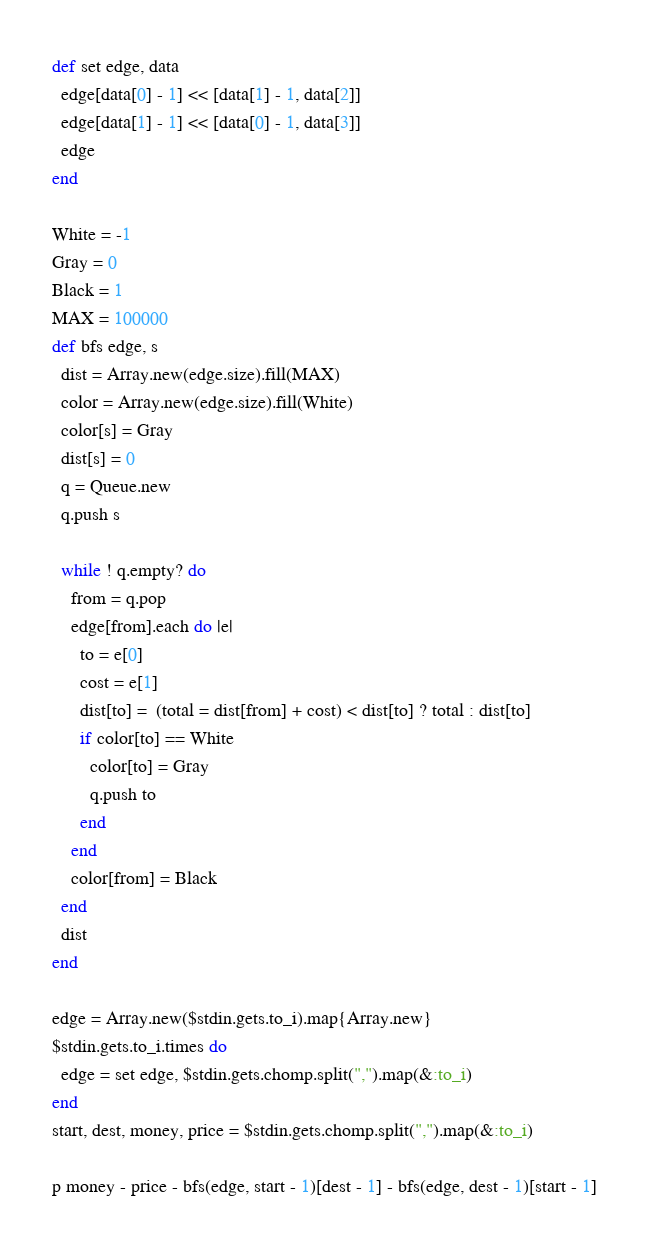Convert code to text. <code><loc_0><loc_0><loc_500><loc_500><_Ruby_>def set edge, data
  edge[data[0] - 1] << [data[1] - 1, data[2]]
  edge[data[1] - 1] << [data[0] - 1, data[3]]
  edge
end

White = -1
Gray = 0
Black = 1
MAX = 100000
def bfs edge, s
  dist = Array.new(edge.size).fill(MAX)
  color = Array.new(edge.size).fill(White)
  color[s] = Gray
  dist[s] = 0
  q = Queue.new
  q.push s

  while ! q.empty? do
    from = q.pop
    edge[from].each do |e|
      to = e[0]
      cost = e[1]
      dist[to] =  (total = dist[from] + cost) < dist[to] ? total : dist[to]
      if color[to] == White
        color[to] = Gray
        q.push to
      end
    end
    color[from] = Black
  end
  dist
end

edge = Array.new($stdin.gets.to_i).map{Array.new}
$stdin.gets.to_i.times do
  edge = set edge, $stdin.gets.chomp.split(",").map(&:to_i)
end
start, dest, money, price = $stdin.gets.chomp.split(",").map(&:to_i)

p money - price - bfs(edge, start - 1)[dest - 1] - bfs(edge, dest - 1)[start - 1]</code> 